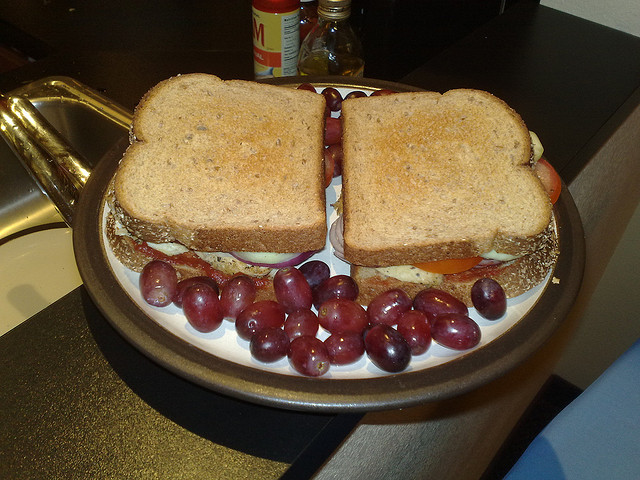Read all the text in this image. M 